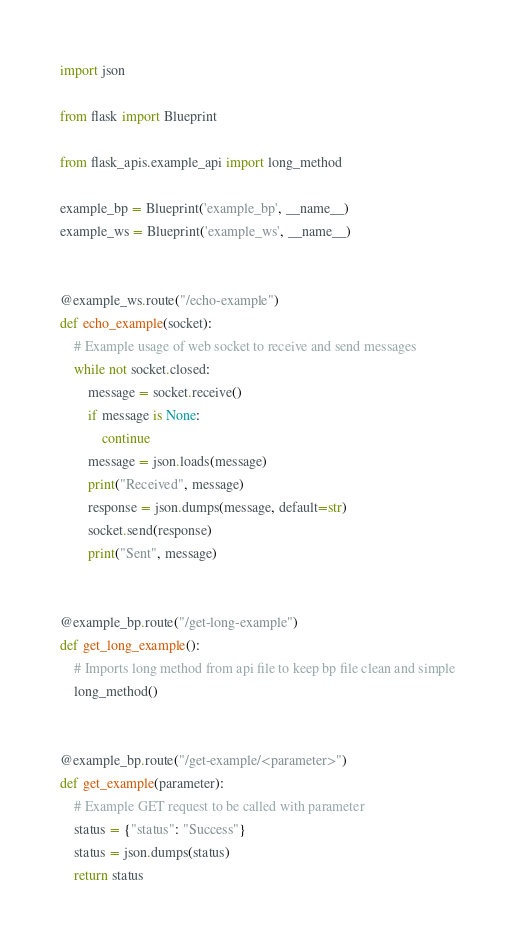<code> <loc_0><loc_0><loc_500><loc_500><_Python_>import json

from flask import Blueprint

from flask_apis.example_api import long_method

example_bp = Blueprint('example_bp', __name__)
example_ws = Blueprint('example_ws', __name__)


@example_ws.route("/echo-example")
def echo_example(socket):
    # Example usage of web socket to receive and send messages
    while not socket.closed:
        message = socket.receive()
        if message is None:
            continue
        message = json.loads(message)
        print("Received", message)
        response = json.dumps(message, default=str)
        socket.send(response)
        print("Sent", message)


@example_bp.route("/get-long-example")
def get_long_example():
    # Imports long method from api file to keep bp file clean and simple
    long_method()


@example_bp.route("/get-example/<parameter>")
def get_example(parameter):
    # Example GET request to be called with parameter
    status = {"status": "Success"}
    status = json.dumps(status)
    return status
</code> 